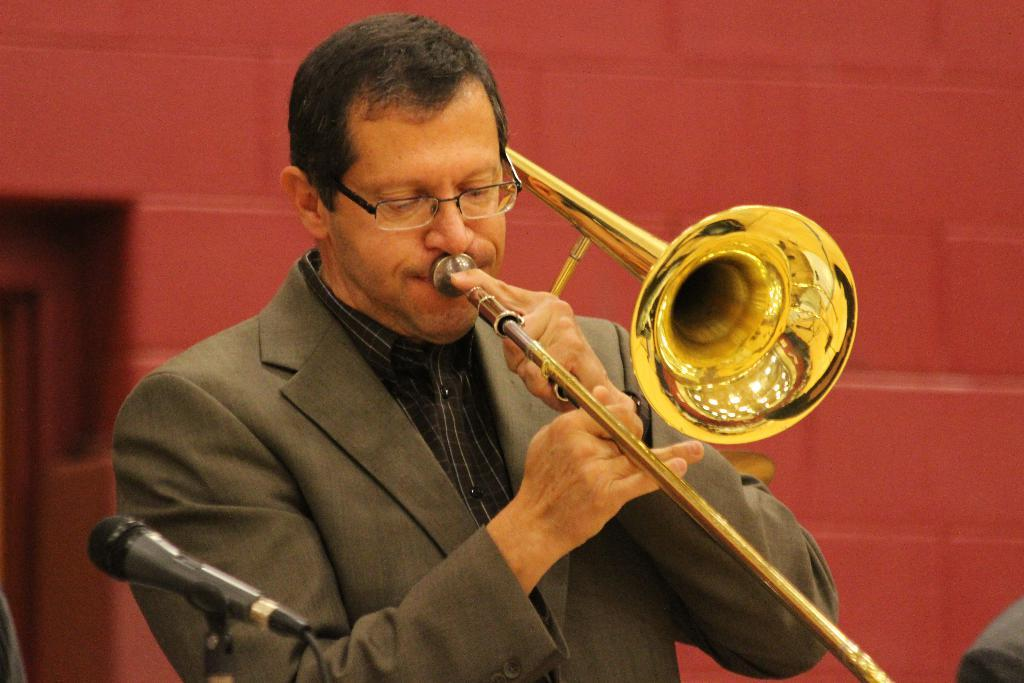What is the person in the image doing? The person is playing a musical instrument in the image. Can you describe any equipment near the person? Yes, there is a microphone on the left side of the image. What color is the wall in the background of the image? The wall in the background of the image is red. What is the income of the person playing the musical instrument in the image? There is no information about the person's income in the image. 